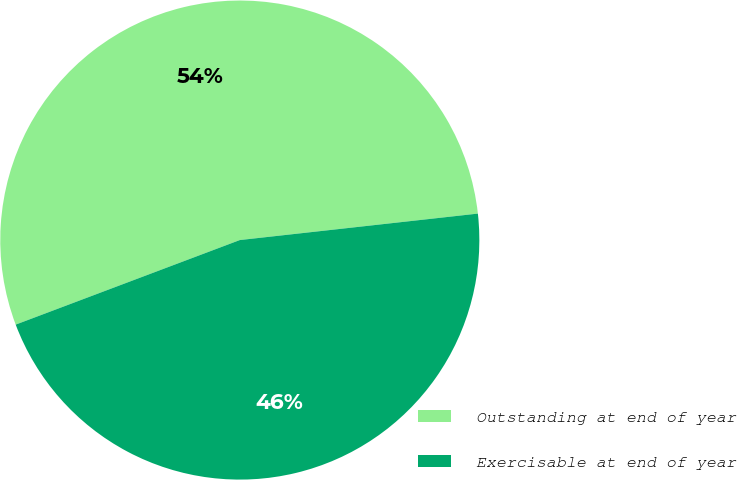<chart> <loc_0><loc_0><loc_500><loc_500><pie_chart><fcel>Outstanding at end of year<fcel>Exercisable at end of year<nl><fcel>53.98%<fcel>46.02%<nl></chart> 